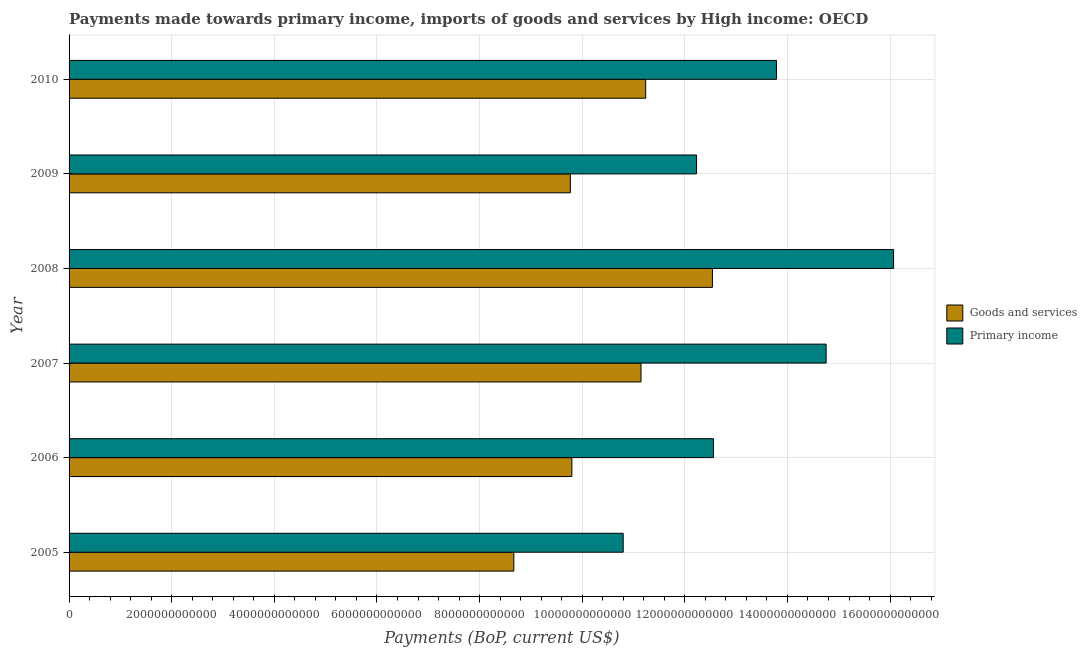How many different coloured bars are there?
Your response must be concise. 2. Are the number of bars per tick equal to the number of legend labels?
Ensure brevity in your answer.  Yes. Are the number of bars on each tick of the Y-axis equal?
Your answer should be very brief. Yes. What is the label of the 5th group of bars from the top?
Your response must be concise. 2006. What is the payments made towards goods and services in 2010?
Keep it short and to the point. 1.12e+13. Across all years, what is the maximum payments made towards primary income?
Keep it short and to the point. 1.61e+13. Across all years, what is the minimum payments made towards primary income?
Offer a terse response. 1.08e+13. What is the total payments made towards goods and services in the graph?
Provide a short and direct response. 6.32e+13. What is the difference between the payments made towards primary income in 2006 and that in 2007?
Your response must be concise. -2.20e+12. What is the difference between the payments made towards primary income in 2006 and the payments made towards goods and services in 2005?
Keep it short and to the point. 3.89e+12. What is the average payments made towards goods and services per year?
Provide a succinct answer. 1.05e+13. In the year 2010, what is the difference between the payments made towards primary income and payments made towards goods and services?
Make the answer very short. 2.55e+12. In how many years, is the payments made towards goods and services greater than 800000000000 US$?
Your answer should be very brief. 6. What is the ratio of the payments made towards goods and services in 2008 to that in 2010?
Provide a succinct answer. 1.12. What is the difference between the highest and the second highest payments made towards goods and services?
Offer a terse response. 1.30e+12. What is the difference between the highest and the lowest payments made towards goods and services?
Provide a short and direct response. 3.87e+12. In how many years, is the payments made towards goods and services greater than the average payments made towards goods and services taken over all years?
Your answer should be very brief. 3. Is the sum of the payments made towards primary income in 2006 and 2007 greater than the maximum payments made towards goods and services across all years?
Your response must be concise. Yes. What does the 2nd bar from the top in 2007 represents?
Your response must be concise. Goods and services. What does the 1st bar from the bottom in 2010 represents?
Make the answer very short. Goods and services. Are all the bars in the graph horizontal?
Your answer should be very brief. Yes. What is the difference between two consecutive major ticks on the X-axis?
Make the answer very short. 2.00e+12. Does the graph contain any zero values?
Your response must be concise. No. Where does the legend appear in the graph?
Ensure brevity in your answer.  Center right. How many legend labels are there?
Give a very brief answer. 2. How are the legend labels stacked?
Your response must be concise. Vertical. What is the title of the graph?
Offer a terse response. Payments made towards primary income, imports of goods and services by High income: OECD. What is the label or title of the X-axis?
Make the answer very short. Payments (BoP, current US$). What is the Payments (BoP, current US$) in Goods and services in 2005?
Offer a terse response. 8.67e+12. What is the Payments (BoP, current US$) of Primary income in 2005?
Your answer should be very brief. 1.08e+13. What is the Payments (BoP, current US$) of Goods and services in 2006?
Give a very brief answer. 9.80e+12. What is the Payments (BoP, current US$) of Primary income in 2006?
Your answer should be very brief. 1.26e+13. What is the Payments (BoP, current US$) of Goods and services in 2007?
Offer a very short reply. 1.11e+13. What is the Payments (BoP, current US$) in Primary income in 2007?
Your answer should be very brief. 1.48e+13. What is the Payments (BoP, current US$) of Goods and services in 2008?
Provide a short and direct response. 1.25e+13. What is the Payments (BoP, current US$) of Primary income in 2008?
Your answer should be very brief. 1.61e+13. What is the Payments (BoP, current US$) of Goods and services in 2009?
Your answer should be very brief. 9.77e+12. What is the Payments (BoP, current US$) in Primary income in 2009?
Offer a very short reply. 1.22e+13. What is the Payments (BoP, current US$) in Goods and services in 2010?
Provide a succinct answer. 1.12e+13. What is the Payments (BoP, current US$) in Primary income in 2010?
Provide a succinct answer. 1.38e+13. Across all years, what is the maximum Payments (BoP, current US$) in Goods and services?
Make the answer very short. 1.25e+13. Across all years, what is the maximum Payments (BoP, current US$) of Primary income?
Give a very brief answer. 1.61e+13. Across all years, what is the minimum Payments (BoP, current US$) in Goods and services?
Your answer should be compact. 8.67e+12. Across all years, what is the minimum Payments (BoP, current US$) in Primary income?
Your response must be concise. 1.08e+13. What is the total Payments (BoP, current US$) in Goods and services in the graph?
Ensure brevity in your answer.  6.32e+13. What is the total Payments (BoP, current US$) in Primary income in the graph?
Offer a very short reply. 8.02e+13. What is the difference between the Payments (BoP, current US$) of Goods and services in 2005 and that in 2006?
Give a very brief answer. -1.13e+12. What is the difference between the Payments (BoP, current US$) of Primary income in 2005 and that in 2006?
Your answer should be very brief. -1.76e+12. What is the difference between the Payments (BoP, current US$) in Goods and services in 2005 and that in 2007?
Ensure brevity in your answer.  -2.48e+12. What is the difference between the Payments (BoP, current US$) in Primary income in 2005 and that in 2007?
Offer a very short reply. -3.96e+12. What is the difference between the Payments (BoP, current US$) of Goods and services in 2005 and that in 2008?
Offer a very short reply. -3.87e+12. What is the difference between the Payments (BoP, current US$) of Primary income in 2005 and that in 2008?
Keep it short and to the point. -5.27e+12. What is the difference between the Payments (BoP, current US$) in Goods and services in 2005 and that in 2009?
Provide a short and direct response. -1.10e+12. What is the difference between the Payments (BoP, current US$) in Primary income in 2005 and that in 2009?
Offer a very short reply. -1.43e+12. What is the difference between the Payments (BoP, current US$) in Goods and services in 2005 and that in 2010?
Provide a succinct answer. -2.57e+12. What is the difference between the Payments (BoP, current US$) in Primary income in 2005 and that in 2010?
Your response must be concise. -2.99e+12. What is the difference between the Payments (BoP, current US$) of Goods and services in 2006 and that in 2007?
Ensure brevity in your answer.  -1.35e+12. What is the difference between the Payments (BoP, current US$) in Primary income in 2006 and that in 2007?
Make the answer very short. -2.20e+12. What is the difference between the Payments (BoP, current US$) of Goods and services in 2006 and that in 2008?
Offer a very short reply. -2.74e+12. What is the difference between the Payments (BoP, current US$) in Primary income in 2006 and that in 2008?
Offer a terse response. -3.51e+12. What is the difference between the Payments (BoP, current US$) of Goods and services in 2006 and that in 2009?
Offer a very short reply. 2.99e+1. What is the difference between the Payments (BoP, current US$) of Primary income in 2006 and that in 2009?
Your response must be concise. 3.28e+11. What is the difference between the Payments (BoP, current US$) in Goods and services in 2006 and that in 2010?
Give a very brief answer. -1.44e+12. What is the difference between the Payments (BoP, current US$) of Primary income in 2006 and that in 2010?
Offer a terse response. -1.23e+12. What is the difference between the Payments (BoP, current US$) in Goods and services in 2007 and that in 2008?
Provide a succinct answer. -1.39e+12. What is the difference between the Payments (BoP, current US$) of Primary income in 2007 and that in 2008?
Give a very brief answer. -1.31e+12. What is the difference between the Payments (BoP, current US$) in Goods and services in 2007 and that in 2009?
Ensure brevity in your answer.  1.38e+12. What is the difference between the Payments (BoP, current US$) of Primary income in 2007 and that in 2009?
Give a very brief answer. 2.53e+12. What is the difference between the Payments (BoP, current US$) in Goods and services in 2007 and that in 2010?
Your response must be concise. -9.06e+1. What is the difference between the Payments (BoP, current US$) of Primary income in 2007 and that in 2010?
Your response must be concise. 9.68e+11. What is the difference between the Payments (BoP, current US$) in Goods and services in 2008 and that in 2009?
Give a very brief answer. 2.77e+12. What is the difference between the Payments (BoP, current US$) of Primary income in 2008 and that in 2009?
Offer a terse response. 3.84e+12. What is the difference between the Payments (BoP, current US$) in Goods and services in 2008 and that in 2010?
Make the answer very short. 1.30e+12. What is the difference between the Payments (BoP, current US$) of Primary income in 2008 and that in 2010?
Your answer should be compact. 2.28e+12. What is the difference between the Payments (BoP, current US$) in Goods and services in 2009 and that in 2010?
Keep it short and to the point. -1.47e+12. What is the difference between the Payments (BoP, current US$) of Primary income in 2009 and that in 2010?
Provide a succinct answer. -1.56e+12. What is the difference between the Payments (BoP, current US$) in Goods and services in 2005 and the Payments (BoP, current US$) in Primary income in 2006?
Your answer should be compact. -3.89e+12. What is the difference between the Payments (BoP, current US$) of Goods and services in 2005 and the Payments (BoP, current US$) of Primary income in 2007?
Offer a terse response. -6.09e+12. What is the difference between the Payments (BoP, current US$) in Goods and services in 2005 and the Payments (BoP, current US$) in Primary income in 2008?
Your answer should be compact. -7.40e+12. What is the difference between the Payments (BoP, current US$) of Goods and services in 2005 and the Payments (BoP, current US$) of Primary income in 2009?
Your response must be concise. -3.56e+12. What is the difference between the Payments (BoP, current US$) of Goods and services in 2005 and the Payments (BoP, current US$) of Primary income in 2010?
Your answer should be very brief. -5.12e+12. What is the difference between the Payments (BoP, current US$) of Goods and services in 2006 and the Payments (BoP, current US$) of Primary income in 2007?
Ensure brevity in your answer.  -4.96e+12. What is the difference between the Payments (BoP, current US$) in Goods and services in 2006 and the Payments (BoP, current US$) in Primary income in 2008?
Make the answer very short. -6.27e+12. What is the difference between the Payments (BoP, current US$) of Goods and services in 2006 and the Payments (BoP, current US$) of Primary income in 2009?
Keep it short and to the point. -2.43e+12. What is the difference between the Payments (BoP, current US$) of Goods and services in 2006 and the Payments (BoP, current US$) of Primary income in 2010?
Make the answer very short. -3.99e+12. What is the difference between the Payments (BoP, current US$) of Goods and services in 2007 and the Payments (BoP, current US$) of Primary income in 2008?
Your answer should be very brief. -4.92e+12. What is the difference between the Payments (BoP, current US$) of Goods and services in 2007 and the Payments (BoP, current US$) of Primary income in 2009?
Ensure brevity in your answer.  -1.08e+12. What is the difference between the Payments (BoP, current US$) of Goods and services in 2007 and the Payments (BoP, current US$) of Primary income in 2010?
Keep it short and to the point. -2.64e+12. What is the difference between the Payments (BoP, current US$) in Goods and services in 2008 and the Payments (BoP, current US$) in Primary income in 2009?
Provide a succinct answer. 3.09e+11. What is the difference between the Payments (BoP, current US$) in Goods and services in 2008 and the Payments (BoP, current US$) in Primary income in 2010?
Your response must be concise. -1.25e+12. What is the difference between the Payments (BoP, current US$) in Goods and services in 2009 and the Payments (BoP, current US$) in Primary income in 2010?
Make the answer very short. -4.02e+12. What is the average Payments (BoP, current US$) in Goods and services per year?
Offer a very short reply. 1.05e+13. What is the average Payments (BoP, current US$) in Primary income per year?
Ensure brevity in your answer.  1.34e+13. In the year 2005, what is the difference between the Payments (BoP, current US$) in Goods and services and Payments (BoP, current US$) in Primary income?
Your answer should be compact. -2.13e+12. In the year 2006, what is the difference between the Payments (BoP, current US$) in Goods and services and Payments (BoP, current US$) in Primary income?
Offer a very short reply. -2.76e+12. In the year 2007, what is the difference between the Payments (BoP, current US$) in Goods and services and Payments (BoP, current US$) in Primary income?
Your response must be concise. -3.61e+12. In the year 2008, what is the difference between the Payments (BoP, current US$) of Goods and services and Payments (BoP, current US$) of Primary income?
Your answer should be very brief. -3.53e+12. In the year 2009, what is the difference between the Payments (BoP, current US$) of Goods and services and Payments (BoP, current US$) of Primary income?
Ensure brevity in your answer.  -2.46e+12. In the year 2010, what is the difference between the Payments (BoP, current US$) in Goods and services and Payments (BoP, current US$) in Primary income?
Your response must be concise. -2.55e+12. What is the ratio of the Payments (BoP, current US$) of Goods and services in 2005 to that in 2006?
Provide a short and direct response. 0.88. What is the ratio of the Payments (BoP, current US$) in Primary income in 2005 to that in 2006?
Keep it short and to the point. 0.86. What is the ratio of the Payments (BoP, current US$) in Goods and services in 2005 to that in 2007?
Your answer should be compact. 0.78. What is the ratio of the Payments (BoP, current US$) in Primary income in 2005 to that in 2007?
Offer a very short reply. 0.73. What is the ratio of the Payments (BoP, current US$) of Goods and services in 2005 to that in 2008?
Ensure brevity in your answer.  0.69. What is the ratio of the Payments (BoP, current US$) in Primary income in 2005 to that in 2008?
Your answer should be very brief. 0.67. What is the ratio of the Payments (BoP, current US$) in Goods and services in 2005 to that in 2009?
Provide a succinct answer. 0.89. What is the ratio of the Payments (BoP, current US$) of Primary income in 2005 to that in 2009?
Ensure brevity in your answer.  0.88. What is the ratio of the Payments (BoP, current US$) in Goods and services in 2005 to that in 2010?
Your response must be concise. 0.77. What is the ratio of the Payments (BoP, current US$) of Primary income in 2005 to that in 2010?
Make the answer very short. 0.78. What is the ratio of the Payments (BoP, current US$) of Goods and services in 2006 to that in 2007?
Your response must be concise. 0.88. What is the ratio of the Payments (BoP, current US$) in Primary income in 2006 to that in 2007?
Give a very brief answer. 0.85. What is the ratio of the Payments (BoP, current US$) of Goods and services in 2006 to that in 2008?
Make the answer very short. 0.78. What is the ratio of the Payments (BoP, current US$) of Primary income in 2006 to that in 2008?
Offer a very short reply. 0.78. What is the ratio of the Payments (BoP, current US$) of Primary income in 2006 to that in 2009?
Offer a very short reply. 1.03. What is the ratio of the Payments (BoP, current US$) in Goods and services in 2006 to that in 2010?
Give a very brief answer. 0.87. What is the ratio of the Payments (BoP, current US$) in Primary income in 2006 to that in 2010?
Ensure brevity in your answer.  0.91. What is the ratio of the Payments (BoP, current US$) of Goods and services in 2007 to that in 2008?
Ensure brevity in your answer.  0.89. What is the ratio of the Payments (BoP, current US$) of Primary income in 2007 to that in 2008?
Your answer should be compact. 0.92. What is the ratio of the Payments (BoP, current US$) of Goods and services in 2007 to that in 2009?
Provide a short and direct response. 1.14. What is the ratio of the Payments (BoP, current US$) of Primary income in 2007 to that in 2009?
Keep it short and to the point. 1.21. What is the ratio of the Payments (BoP, current US$) of Primary income in 2007 to that in 2010?
Your answer should be compact. 1.07. What is the ratio of the Payments (BoP, current US$) in Goods and services in 2008 to that in 2009?
Your answer should be very brief. 1.28. What is the ratio of the Payments (BoP, current US$) of Primary income in 2008 to that in 2009?
Make the answer very short. 1.31. What is the ratio of the Payments (BoP, current US$) in Goods and services in 2008 to that in 2010?
Offer a very short reply. 1.12. What is the ratio of the Payments (BoP, current US$) of Primary income in 2008 to that in 2010?
Keep it short and to the point. 1.17. What is the ratio of the Payments (BoP, current US$) in Goods and services in 2009 to that in 2010?
Give a very brief answer. 0.87. What is the ratio of the Payments (BoP, current US$) of Primary income in 2009 to that in 2010?
Your answer should be very brief. 0.89. What is the difference between the highest and the second highest Payments (BoP, current US$) of Goods and services?
Provide a succinct answer. 1.30e+12. What is the difference between the highest and the second highest Payments (BoP, current US$) of Primary income?
Your response must be concise. 1.31e+12. What is the difference between the highest and the lowest Payments (BoP, current US$) of Goods and services?
Offer a very short reply. 3.87e+12. What is the difference between the highest and the lowest Payments (BoP, current US$) in Primary income?
Make the answer very short. 5.27e+12. 